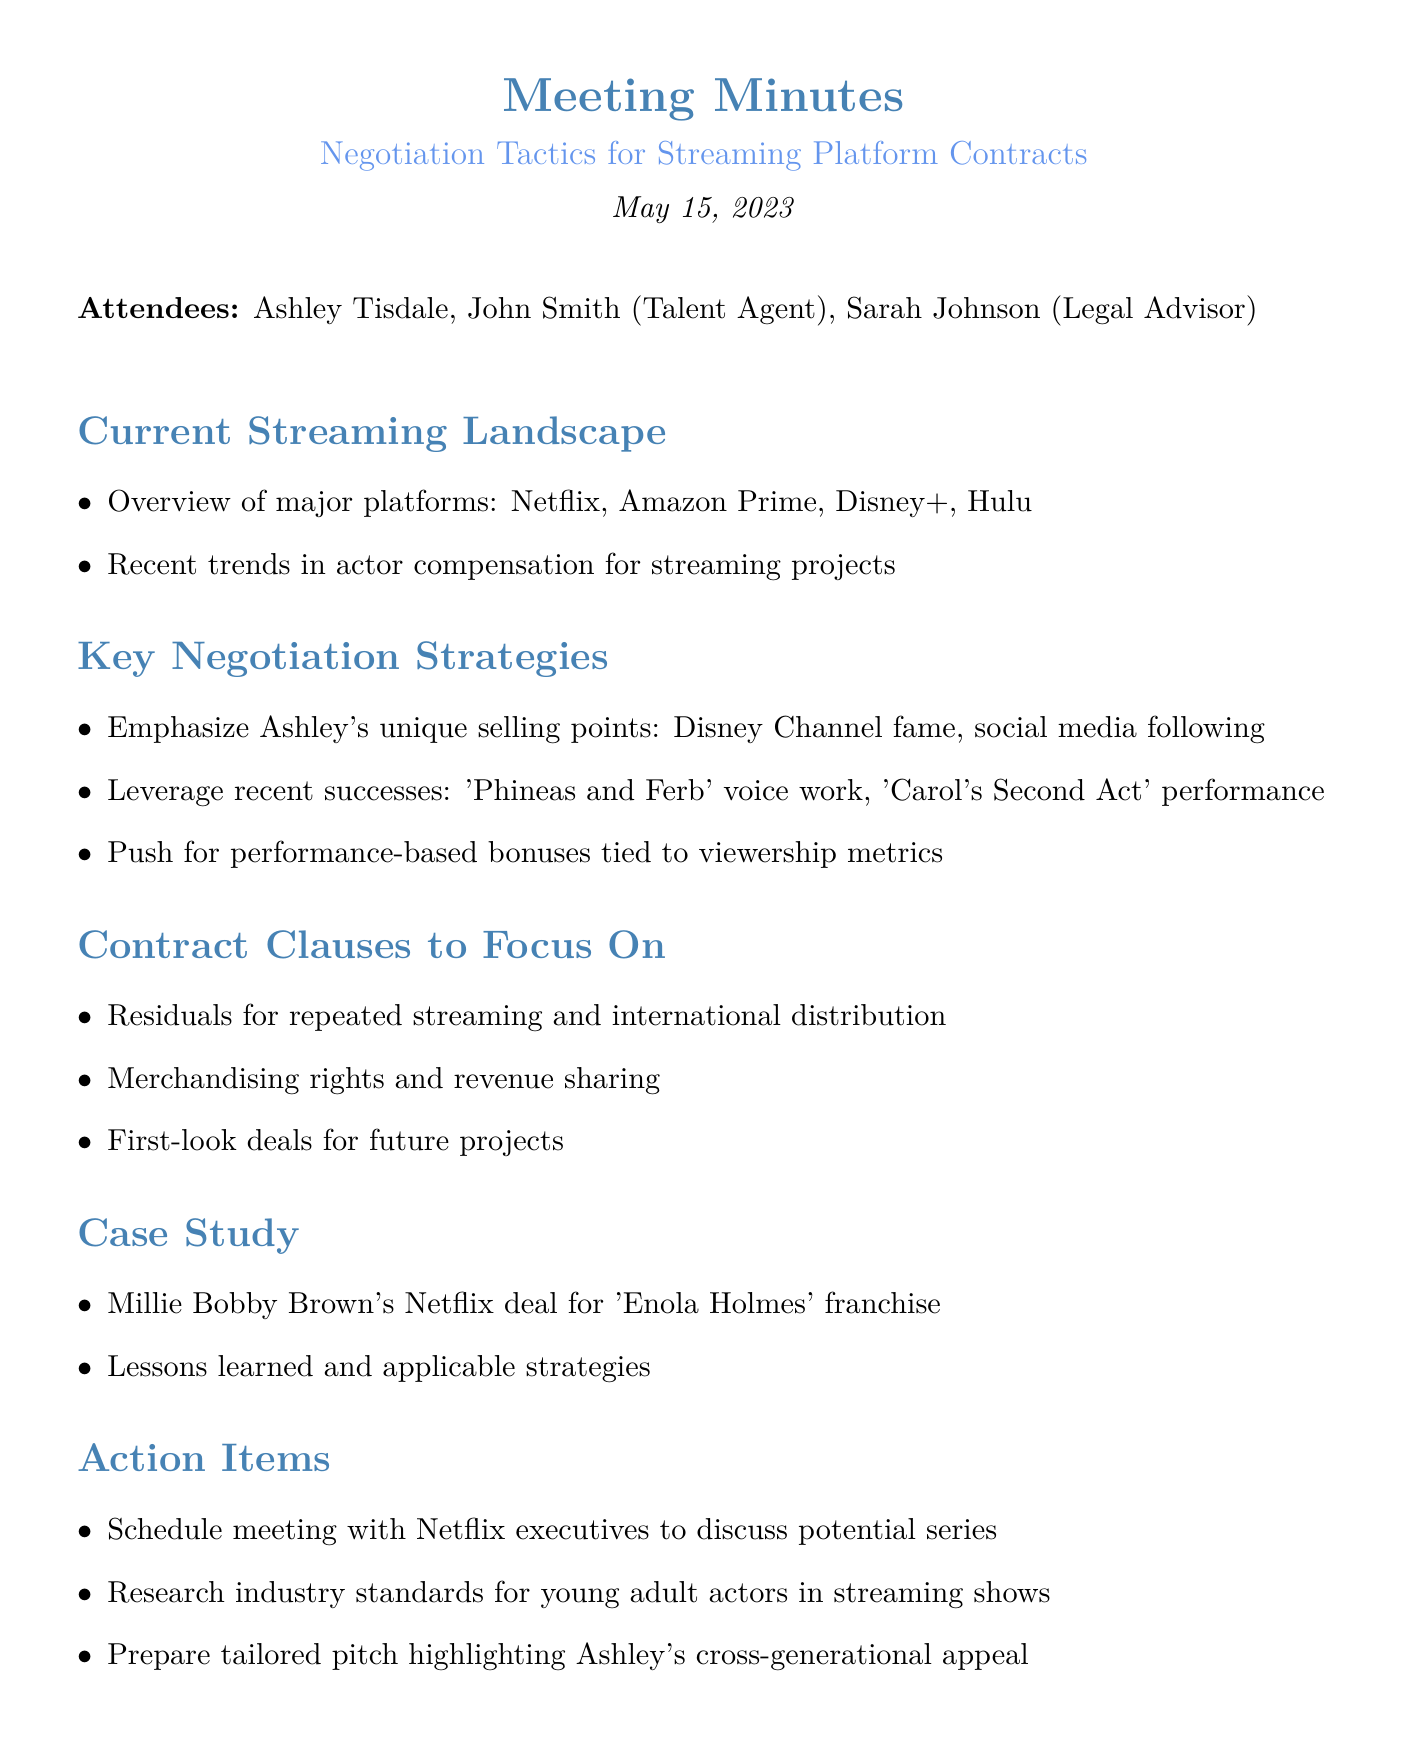What is the date of the meeting? The date of the meeting is provided in the document under the title section.
Answer: May 15, 2023 Who is the legal advisor present at the meeting? The document lists attendees and specifies each person's role.
Answer: Sarah Johnson Which streaming platforms are mentioned in the current landscape? The section on the current streaming landscape lists major platforms directly.
Answer: Netflix, Amazon Prime, Disney+, Hulu What is one of Ashley's unique selling points discussed in the meeting? The meeting minutes detail specific points regarding Ashley's appeal, including fame and social presence.
Answer: Disney Channel fame What contract clause relates to repeated streaming? The document explicitly mentions specific contract clauses to focus on regarding compensation.
Answer: Residuals for repeated streaming and international distribution What was the case study about? The case study section describes a specific deal related to a notable actress.
Answer: Millie Bobby Brown's Netflix deal for 'Enola Holmes' franchise What action item involves meeting with Netflix? The action items clearly list tasks for follow-up actions after the meeting.
Answer: Schedule meeting with Netflix executives to discuss potential series What type of bonuses were recommended to be pushed for in negotiations? The strategies discussed include specifics on compensation structures based on performance metrics.
Answer: Performance-based bonuses tied to viewership metrics 